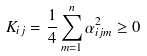<formula> <loc_0><loc_0><loc_500><loc_500>K _ { i j } = \frac { 1 } { 4 } \sum _ { m = 1 } ^ { n } \alpha ^ { 2 } _ { i j m } \geq 0</formula> 